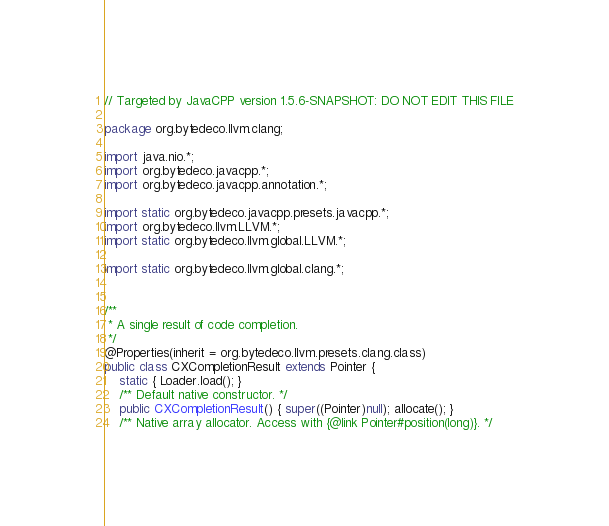Convert code to text. <code><loc_0><loc_0><loc_500><loc_500><_Java_>// Targeted by JavaCPP version 1.5.6-SNAPSHOT: DO NOT EDIT THIS FILE

package org.bytedeco.llvm.clang;

import java.nio.*;
import org.bytedeco.javacpp.*;
import org.bytedeco.javacpp.annotation.*;

import static org.bytedeco.javacpp.presets.javacpp.*;
import org.bytedeco.llvm.LLVM.*;
import static org.bytedeco.llvm.global.LLVM.*;

import static org.bytedeco.llvm.global.clang.*;


/**
 * A single result of code completion.
 */
@Properties(inherit = org.bytedeco.llvm.presets.clang.class)
public class CXCompletionResult extends Pointer {
    static { Loader.load(); }
    /** Default native constructor. */
    public CXCompletionResult() { super((Pointer)null); allocate(); }
    /** Native array allocator. Access with {@link Pointer#position(long)}. */</code> 